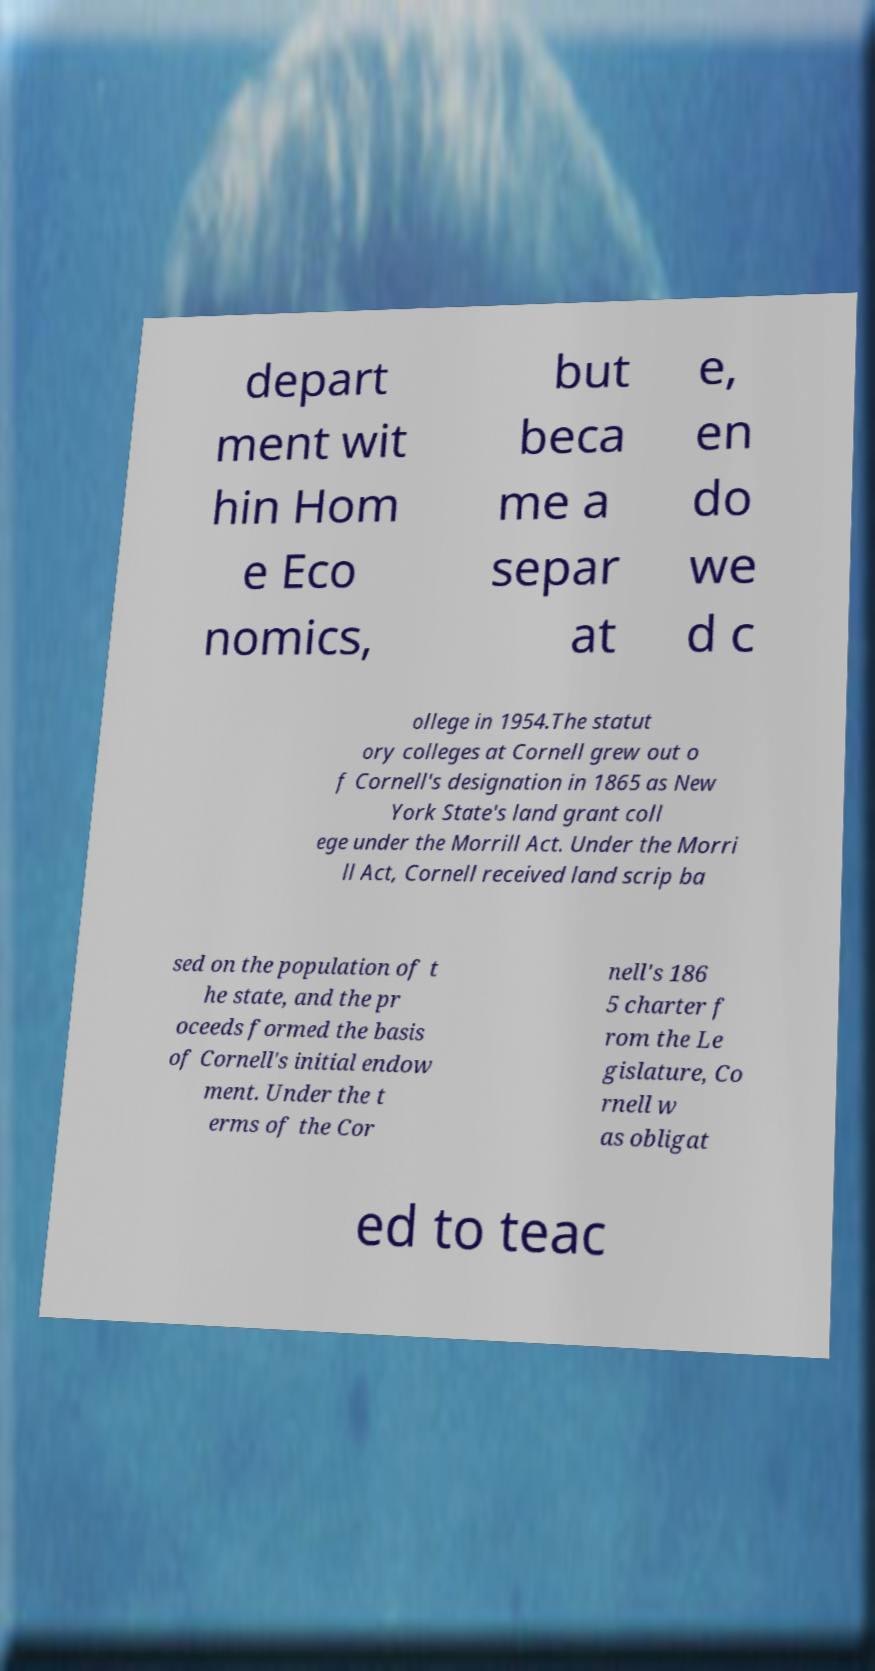I need the written content from this picture converted into text. Can you do that? depart ment wit hin Hom e Eco nomics, but beca me a separ at e, en do we d c ollege in 1954.The statut ory colleges at Cornell grew out o f Cornell's designation in 1865 as New York State's land grant coll ege under the Morrill Act. Under the Morri ll Act, Cornell received land scrip ba sed on the population of t he state, and the pr oceeds formed the basis of Cornell's initial endow ment. Under the t erms of the Cor nell's 186 5 charter f rom the Le gislature, Co rnell w as obligat ed to teac 